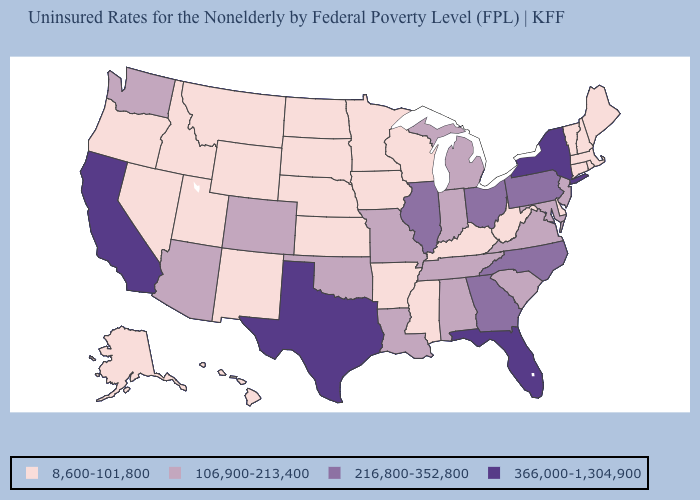Does Hawaii have a higher value than Arkansas?
Keep it brief. No. Among the states that border Alabama , does Florida have the highest value?
Be succinct. Yes. What is the value of Connecticut?
Answer briefly. 8,600-101,800. What is the highest value in the West ?
Give a very brief answer. 366,000-1,304,900. What is the value of Rhode Island?
Keep it brief. 8,600-101,800. What is the value of Virginia?
Write a very short answer. 106,900-213,400. What is the value of Delaware?
Answer briefly. 8,600-101,800. Which states have the lowest value in the USA?
Concise answer only. Alaska, Arkansas, Connecticut, Delaware, Hawaii, Idaho, Iowa, Kansas, Kentucky, Maine, Massachusetts, Minnesota, Mississippi, Montana, Nebraska, Nevada, New Hampshire, New Mexico, North Dakota, Oregon, Rhode Island, South Dakota, Utah, Vermont, West Virginia, Wisconsin, Wyoming. Among the states that border Oklahoma , does Colorado have the lowest value?
Keep it brief. No. What is the value of Florida?
Concise answer only. 366,000-1,304,900. What is the lowest value in the USA?
Write a very short answer. 8,600-101,800. Does the map have missing data?
Keep it brief. No. Which states have the lowest value in the South?
Concise answer only. Arkansas, Delaware, Kentucky, Mississippi, West Virginia. Which states hav the highest value in the South?
Answer briefly. Florida, Texas. What is the value of Indiana?
Keep it brief. 106,900-213,400. 